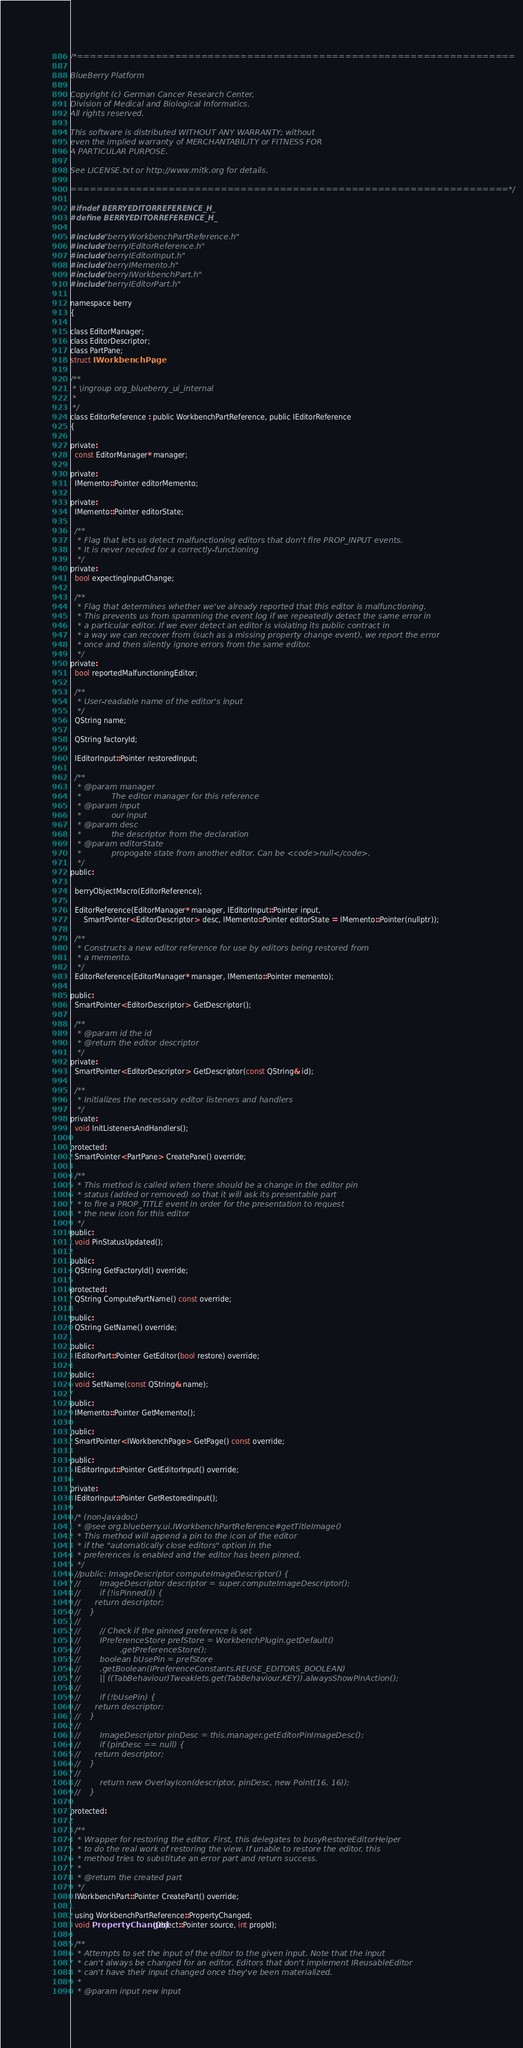Convert code to text. <code><loc_0><loc_0><loc_500><loc_500><_C_>/*===================================================================

BlueBerry Platform

Copyright (c) German Cancer Research Center,
Division of Medical and Biological Informatics.
All rights reserved.

This software is distributed WITHOUT ANY WARRANTY; without
even the implied warranty of MERCHANTABILITY or FITNESS FOR
A PARTICULAR PURPOSE.

See LICENSE.txt or http://www.mitk.org for details.

===================================================================*/

#ifndef BERRYEDITORREFERENCE_H_
#define BERRYEDITORREFERENCE_H_

#include "berryWorkbenchPartReference.h"
#include "berryIEditorReference.h"
#include "berryIEditorInput.h"
#include "berryIMemento.h"
#include "berryIWorkbenchPart.h"
#include "berryIEditorPart.h"

namespace berry
{

class EditorManager;
class EditorDescriptor;
class PartPane;
struct IWorkbenchPage;

/**
 * \ingroup org_blueberry_ui_internal
 *
 */
class EditorReference : public WorkbenchPartReference, public IEditorReference
{

private:
  const EditorManager* manager;

private:
  IMemento::Pointer editorMemento;

private:
  IMemento::Pointer editorState;

  /**
   * Flag that lets us detect malfunctioning editors that don't fire PROP_INPUT events.
   * It is never needed for a correctly-functioning
   */
private:
  bool expectingInputChange;

  /**
   * Flag that determines whether we've already reported that this editor is malfunctioning.
   * This prevents us from spamming the event log if we repeatedly detect the same error in
   * a particular editor. If we ever detect an editor is violating its public contract in
   * a way we can recover from (such as a missing property change event), we report the error
   * once and then silently ignore errors from the same editor.
   */
private:
  bool reportedMalfunctioningEditor;

  /**
   * User-readable name of the editor's input
   */
  QString name;

  QString factoryId;

  IEditorInput::Pointer restoredInput;

  /**
   * @param manager
   *            The editor manager for this reference
   * @param input
   *            our input
   * @param desc
   *            the descriptor from the declaration
   * @param editorState
   *            propogate state from another editor. Can be <code>null</code>.
   */
public:

  berryObjectMacro(EditorReference);

  EditorReference(EditorManager* manager, IEditorInput::Pointer input,
      SmartPointer<EditorDescriptor> desc, IMemento::Pointer editorState = IMemento::Pointer(nullptr));

  /**
   * Constructs a new editor reference for use by editors being restored from
   * a memento.
   */
  EditorReference(EditorManager* manager, IMemento::Pointer memento);

public:
  SmartPointer<EditorDescriptor> GetDescriptor();

  /**
   * @param id the id
   * @return the editor descriptor
   */
private:
  SmartPointer<EditorDescriptor> GetDescriptor(const QString& id);

  /**
   * Initializes the necessary editor listeners and handlers
   */
private:
  void InitListenersAndHandlers();

protected:
  SmartPointer<PartPane> CreatePane() override;

  /**
   * This method is called when there should be a change in the editor pin
   * status (added or removed) so that it will ask its presentable part
   * to fire a PROP_TITLE event in order for the presentation to request
   * the new icon for this editor
   */
public:
  void PinStatusUpdated();

public:
  QString GetFactoryId() override;

protected:
  QString ComputePartName() const override;

public:
  QString GetName() override;

public:
  IEditorPart::Pointer GetEditor(bool restore) override;

public:
  void SetName(const QString& name);

public:
  IMemento::Pointer GetMemento();

public:
  SmartPointer<IWorkbenchPage> GetPage() const override;

public:
  IEditorInput::Pointer GetEditorInput() override;

private:
  IEditorInput::Pointer GetRestoredInput();

  /* (non-Javadoc)
   * @see org.blueberry.ui.IWorkbenchPartReference#getTitleImage()
   * This method will append a pin to the icon of the editor
   * if the "automatically close editors" option in the
   * preferences is enabled and the editor has been pinned.
   */
  //public: ImageDescriptor computeImageDescriptor() {
  //        ImageDescriptor descriptor = super.computeImageDescriptor();
  //        if (!isPinned()) {
  //      return descriptor;
  //    }
  //
  //        // Check if the pinned preference is set
  //        IPreferenceStore prefStore = WorkbenchPlugin.getDefault()
  //                .getPreferenceStore();
  //        boolean bUsePin = prefStore
  //        .getBoolean(IPreferenceConstants.REUSE_EDITORS_BOOLEAN)
  //        || ((TabBehaviour)Tweaklets.get(TabBehaviour.KEY)).alwaysShowPinAction();
  //
  //        if (!bUsePin) {
  //      return descriptor;
  //    }
  //
  //        ImageDescriptor pinDesc = this.manager.getEditorPinImageDesc();
  //        if (pinDesc == null) {
  //      return descriptor;
  //    }
  //
  //        return new OverlayIcon(descriptor, pinDesc, new Point(16, 16));
  //    }

protected:

  /**
   * Wrapper for restoring the editor. First, this delegates to busyRestoreEditorHelper
   * to do the real work of restoring the view. If unable to restore the editor, this
   * method tries to substitute an error part and return success.
   *
   * @return the created part
   */
  IWorkbenchPart::Pointer CreatePart() override;

  using WorkbenchPartReference::PropertyChanged;
  void PropertyChanged(Object::Pointer source, int propId);

  /**
   * Attempts to set the input of the editor to the given input. Note that the input
   * can't always be changed for an editor. Editors that don't implement IReusableEditor
   * can't have their input changed once they've been materialized.
   *
   * @param input new input</code> 